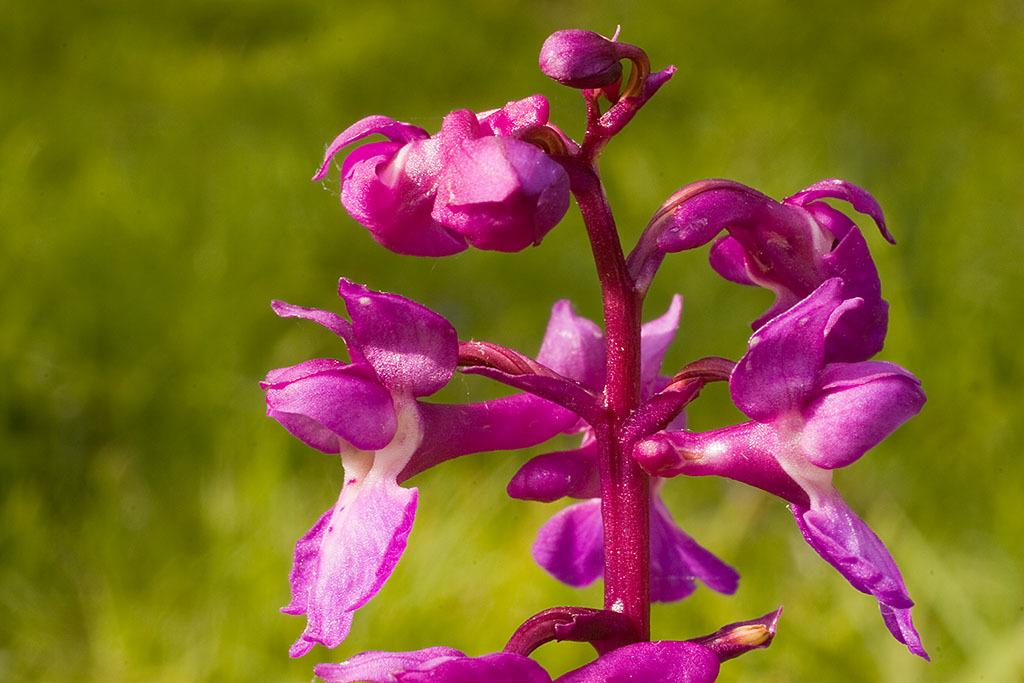What is the color of the stem in the image? The stem is pink in the image. What color are the flowers on the stem? The flowers are also pink in the image. What can be seen in the background of the image? There is a green background in the image. How many bears are visible in the image? There are no bears present in the image. What statement can be made about the flowers in the image? The flowers are pink in the image. 